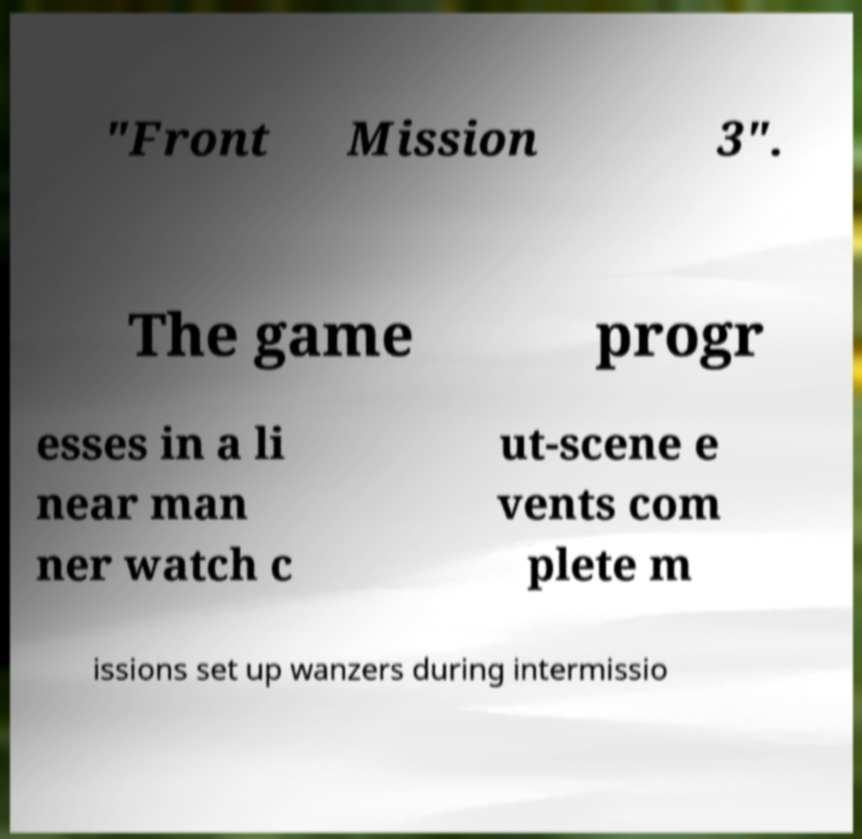I need the written content from this picture converted into text. Can you do that? "Front Mission 3". The game progr esses in a li near man ner watch c ut-scene e vents com plete m issions set up wanzers during intermissio 